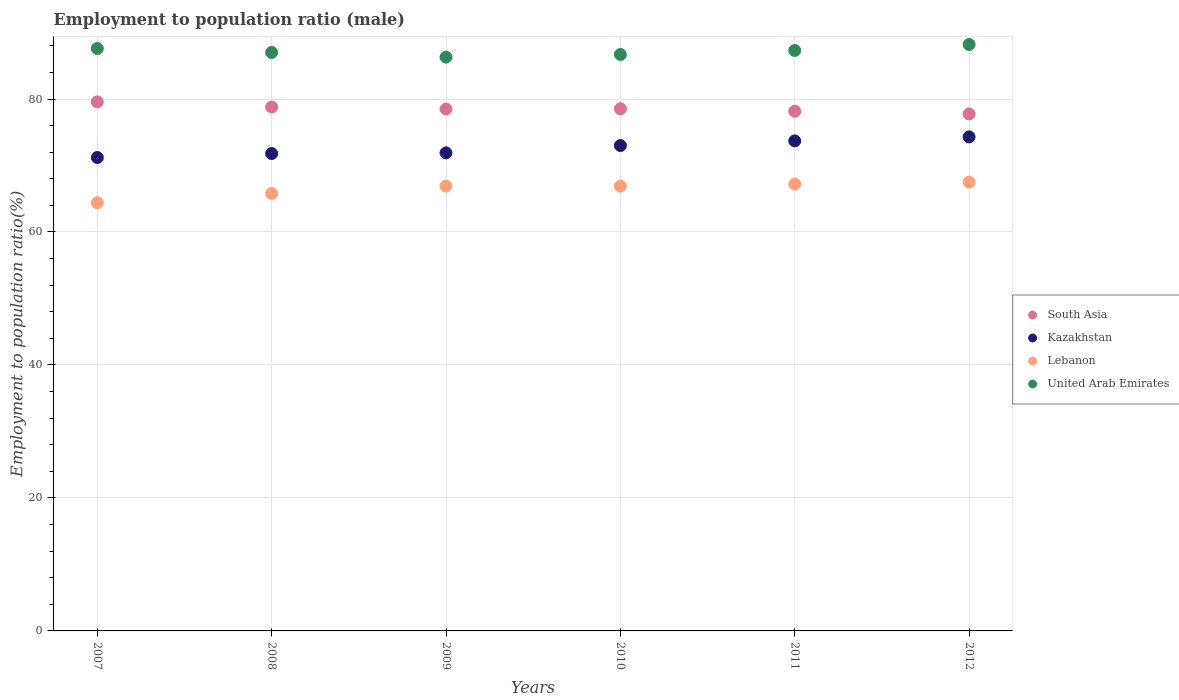How many different coloured dotlines are there?
Offer a terse response. 4. What is the employment to population ratio in Kazakhstan in 2009?
Give a very brief answer. 71.9. Across all years, what is the maximum employment to population ratio in Lebanon?
Your answer should be compact. 67.5. Across all years, what is the minimum employment to population ratio in Kazakhstan?
Make the answer very short. 71.2. What is the total employment to population ratio in Lebanon in the graph?
Keep it short and to the point. 398.7. What is the difference between the employment to population ratio in Kazakhstan in 2007 and that in 2009?
Keep it short and to the point. -0.7. What is the difference between the employment to population ratio in Lebanon in 2011 and the employment to population ratio in Kazakhstan in 2007?
Your response must be concise. -4. What is the average employment to population ratio in Lebanon per year?
Provide a succinct answer. 66.45. In the year 2012, what is the difference between the employment to population ratio in Lebanon and employment to population ratio in Kazakhstan?
Provide a succinct answer. -6.8. What is the ratio of the employment to population ratio in Lebanon in 2009 to that in 2012?
Your answer should be very brief. 0.99. Is the employment to population ratio in Kazakhstan in 2010 less than that in 2011?
Ensure brevity in your answer.  Yes. What is the difference between the highest and the second highest employment to population ratio in Lebanon?
Keep it short and to the point. 0.3. What is the difference between the highest and the lowest employment to population ratio in Kazakhstan?
Keep it short and to the point. 3.1. Is it the case that in every year, the sum of the employment to population ratio in South Asia and employment to population ratio in United Arab Emirates  is greater than the employment to population ratio in Lebanon?
Your response must be concise. Yes. Does the employment to population ratio in South Asia monotonically increase over the years?
Provide a short and direct response. No. Is the employment to population ratio in South Asia strictly less than the employment to population ratio in Lebanon over the years?
Your answer should be compact. No. How many years are there in the graph?
Offer a terse response. 6. What is the difference between two consecutive major ticks on the Y-axis?
Offer a terse response. 20. Does the graph contain grids?
Make the answer very short. Yes. How many legend labels are there?
Ensure brevity in your answer.  4. What is the title of the graph?
Your answer should be compact. Employment to population ratio (male). Does "Myanmar" appear as one of the legend labels in the graph?
Your answer should be compact. No. What is the label or title of the X-axis?
Your answer should be compact. Years. What is the label or title of the Y-axis?
Make the answer very short. Employment to population ratio(%). What is the Employment to population ratio(%) in South Asia in 2007?
Your answer should be compact. 79.56. What is the Employment to population ratio(%) in Kazakhstan in 2007?
Ensure brevity in your answer.  71.2. What is the Employment to population ratio(%) in Lebanon in 2007?
Provide a succinct answer. 64.4. What is the Employment to population ratio(%) of United Arab Emirates in 2007?
Your answer should be very brief. 87.6. What is the Employment to population ratio(%) of South Asia in 2008?
Provide a short and direct response. 78.8. What is the Employment to population ratio(%) in Kazakhstan in 2008?
Your response must be concise. 71.8. What is the Employment to population ratio(%) of Lebanon in 2008?
Provide a short and direct response. 65.8. What is the Employment to population ratio(%) of United Arab Emirates in 2008?
Offer a very short reply. 87. What is the Employment to population ratio(%) of South Asia in 2009?
Offer a very short reply. 78.49. What is the Employment to population ratio(%) in Kazakhstan in 2009?
Offer a very short reply. 71.9. What is the Employment to population ratio(%) in Lebanon in 2009?
Your answer should be very brief. 66.9. What is the Employment to population ratio(%) in United Arab Emirates in 2009?
Ensure brevity in your answer.  86.3. What is the Employment to population ratio(%) in South Asia in 2010?
Provide a short and direct response. 78.53. What is the Employment to population ratio(%) of Lebanon in 2010?
Offer a very short reply. 66.9. What is the Employment to population ratio(%) in United Arab Emirates in 2010?
Provide a succinct answer. 86.7. What is the Employment to population ratio(%) in South Asia in 2011?
Your answer should be very brief. 78.16. What is the Employment to population ratio(%) in Kazakhstan in 2011?
Give a very brief answer. 73.7. What is the Employment to population ratio(%) of Lebanon in 2011?
Provide a short and direct response. 67.2. What is the Employment to population ratio(%) of United Arab Emirates in 2011?
Provide a succinct answer. 87.3. What is the Employment to population ratio(%) of South Asia in 2012?
Ensure brevity in your answer.  77.76. What is the Employment to population ratio(%) in Kazakhstan in 2012?
Provide a short and direct response. 74.3. What is the Employment to population ratio(%) in Lebanon in 2012?
Give a very brief answer. 67.5. What is the Employment to population ratio(%) in United Arab Emirates in 2012?
Offer a terse response. 88.2. Across all years, what is the maximum Employment to population ratio(%) of South Asia?
Make the answer very short. 79.56. Across all years, what is the maximum Employment to population ratio(%) in Kazakhstan?
Provide a succinct answer. 74.3. Across all years, what is the maximum Employment to population ratio(%) of Lebanon?
Keep it short and to the point. 67.5. Across all years, what is the maximum Employment to population ratio(%) in United Arab Emirates?
Offer a terse response. 88.2. Across all years, what is the minimum Employment to population ratio(%) in South Asia?
Provide a short and direct response. 77.76. Across all years, what is the minimum Employment to population ratio(%) of Kazakhstan?
Your response must be concise. 71.2. Across all years, what is the minimum Employment to population ratio(%) of Lebanon?
Offer a terse response. 64.4. Across all years, what is the minimum Employment to population ratio(%) of United Arab Emirates?
Keep it short and to the point. 86.3. What is the total Employment to population ratio(%) of South Asia in the graph?
Offer a very short reply. 471.3. What is the total Employment to population ratio(%) in Kazakhstan in the graph?
Provide a succinct answer. 435.9. What is the total Employment to population ratio(%) in Lebanon in the graph?
Provide a short and direct response. 398.7. What is the total Employment to population ratio(%) of United Arab Emirates in the graph?
Your response must be concise. 523.1. What is the difference between the Employment to population ratio(%) in South Asia in 2007 and that in 2008?
Your answer should be compact. 0.76. What is the difference between the Employment to population ratio(%) in Kazakhstan in 2007 and that in 2008?
Ensure brevity in your answer.  -0.6. What is the difference between the Employment to population ratio(%) of South Asia in 2007 and that in 2009?
Offer a very short reply. 1.07. What is the difference between the Employment to population ratio(%) in Kazakhstan in 2007 and that in 2009?
Provide a short and direct response. -0.7. What is the difference between the Employment to population ratio(%) in Lebanon in 2007 and that in 2009?
Keep it short and to the point. -2.5. What is the difference between the Employment to population ratio(%) in South Asia in 2007 and that in 2010?
Keep it short and to the point. 1.03. What is the difference between the Employment to population ratio(%) of Kazakhstan in 2007 and that in 2010?
Offer a very short reply. -1.8. What is the difference between the Employment to population ratio(%) of South Asia in 2007 and that in 2011?
Your response must be concise. 1.41. What is the difference between the Employment to population ratio(%) in South Asia in 2007 and that in 2012?
Offer a very short reply. 1.8. What is the difference between the Employment to population ratio(%) of Kazakhstan in 2007 and that in 2012?
Make the answer very short. -3.1. What is the difference between the Employment to population ratio(%) of South Asia in 2008 and that in 2009?
Provide a succinct answer. 0.32. What is the difference between the Employment to population ratio(%) in Kazakhstan in 2008 and that in 2009?
Keep it short and to the point. -0.1. What is the difference between the Employment to population ratio(%) in South Asia in 2008 and that in 2010?
Your response must be concise. 0.27. What is the difference between the Employment to population ratio(%) in United Arab Emirates in 2008 and that in 2010?
Offer a very short reply. 0.3. What is the difference between the Employment to population ratio(%) in South Asia in 2008 and that in 2011?
Offer a very short reply. 0.65. What is the difference between the Employment to population ratio(%) of South Asia in 2008 and that in 2012?
Offer a terse response. 1.04. What is the difference between the Employment to population ratio(%) in Kazakhstan in 2008 and that in 2012?
Keep it short and to the point. -2.5. What is the difference between the Employment to population ratio(%) of Lebanon in 2008 and that in 2012?
Make the answer very short. -1.7. What is the difference between the Employment to population ratio(%) of United Arab Emirates in 2008 and that in 2012?
Provide a short and direct response. -1.2. What is the difference between the Employment to population ratio(%) in South Asia in 2009 and that in 2010?
Keep it short and to the point. -0.04. What is the difference between the Employment to population ratio(%) in Kazakhstan in 2009 and that in 2010?
Offer a very short reply. -1.1. What is the difference between the Employment to population ratio(%) in United Arab Emirates in 2009 and that in 2010?
Give a very brief answer. -0.4. What is the difference between the Employment to population ratio(%) of South Asia in 2009 and that in 2011?
Provide a succinct answer. 0.33. What is the difference between the Employment to population ratio(%) in Kazakhstan in 2009 and that in 2011?
Your answer should be compact. -1.8. What is the difference between the Employment to population ratio(%) in Lebanon in 2009 and that in 2011?
Provide a succinct answer. -0.3. What is the difference between the Employment to population ratio(%) in South Asia in 2009 and that in 2012?
Offer a terse response. 0.73. What is the difference between the Employment to population ratio(%) in Kazakhstan in 2009 and that in 2012?
Keep it short and to the point. -2.4. What is the difference between the Employment to population ratio(%) in South Asia in 2010 and that in 2011?
Offer a terse response. 0.37. What is the difference between the Employment to population ratio(%) of South Asia in 2010 and that in 2012?
Provide a succinct answer. 0.77. What is the difference between the Employment to population ratio(%) in United Arab Emirates in 2010 and that in 2012?
Provide a succinct answer. -1.5. What is the difference between the Employment to population ratio(%) of South Asia in 2011 and that in 2012?
Offer a terse response. 0.4. What is the difference between the Employment to population ratio(%) in United Arab Emirates in 2011 and that in 2012?
Give a very brief answer. -0.9. What is the difference between the Employment to population ratio(%) in South Asia in 2007 and the Employment to population ratio(%) in Kazakhstan in 2008?
Make the answer very short. 7.76. What is the difference between the Employment to population ratio(%) in South Asia in 2007 and the Employment to population ratio(%) in Lebanon in 2008?
Your answer should be very brief. 13.76. What is the difference between the Employment to population ratio(%) of South Asia in 2007 and the Employment to population ratio(%) of United Arab Emirates in 2008?
Make the answer very short. -7.44. What is the difference between the Employment to population ratio(%) of Kazakhstan in 2007 and the Employment to population ratio(%) of Lebanon in 2008?
Your answer should be compact. 5.4. What is the difference between the Employment to population ratio(%) in Kazakhstan in 2007 and the Employment to population ratio(%) in United Arab Emirates in 2008?
Make the answer very short. -15.8. What is the difference between the Employment to population ratio(%) in Lebanon in 2007 and the Employment to population ratio(%) in United Arab Emirates in 2008?
Your answer should be very brief. -22.6. What is the difference between the Employment to population ratio(%) of South Asia in 2007 and the Employment to population ratio(%) of Kazakhstan in 2009?
Your response must be concise. 7.66. What is the difference between the Employment to population ratio(%) of South Asia in 2007 and the Employment to population ratio(%) of Lebanon in 2009?
Your response must be concise. 12.66. What is the difference between the Employment to population ratio(%) of South Asia in 2007 and the Employment to population ratio(%) of United Arab Emirates in 2009?
Provide a succinct answer. -6.74. What is the difference between the Employment to population ratio(%) of Kazakhstan in 2007 and the Employment to population ratio(%) of Lebanon in 2009?
Your answer should be compact. 4.3. What is the difference between the Employment to population ratio(%) in Kazakhstan in 2007 and the Employment to population ratio(%) in United Arab Emirates in 2009?
Provide a short and direct response. -15.1. What is the difference between the Employment to population ratio(%) of Lebanon in 2007 and the Employment to population ratio(%) of United Arab Emirates in 2009?
Make the answer very short. -21.9. What is the difference between the Employment to population ratio(%) in South Asia in 2007 and the Employment to population ratio(%) in Kazakhstan in 2010?
Ensure brevity in your answer.  6.56. What is the difference between the Employment to population ratio(%) of South Asia in 2007 and the Employment to population ratio(%) of Lebanon in 2010?
Offer a terse response. 12.66. What is the difference between the Employment to population ratio(%) in South Asia in 2007 and the Employment to population ratio(%) in United Arab Emirates in 2010?
Provide a succinct answer. -7.14. What is the difference between the Employment to population ratio(%) in Kazakhstan in 2007 and the Employment to population ratio(%) in United Arab Emirates in 2010?
Your response must be concise. -15.5. What is the difference between the Employment to population ratio(%) in Lebanon in 2007 and the Employment to population ratio(%) in United Arab Emirates in 2010?
Your answer should be very brief. -22.3. What is the difference between the Employment to population ratio(%) of South Asia in 2007 and the Employment to population ratio(%) of Kazakhstan in 2011?
Offer a terse response. 5.86. What is the difference between the Employment to population ratio(%) in South Asia in 2007 and the Employment to population ratio(%) in Lebanon in 2011?
Ensure brevity in your answer.  12.36. What is the difference between the Employment to population ratio(%) of South Asia in 2007 and the Employment to population ratio(%) of United Arab Emirates in 2011?
Provide a short and direct response. -7.74. What is the difference between the Employment to population ratio(%) in Kazakhstan in 2007 and the Employment to population ratio(%) in Lebanon in 2011?
Your answer should be compact. 4. What is the difference between the Employment to population ratio(%) of Kazakhstan in 2007 and the Employment to population ratio(%) of United Arab Emirates in 2011?
Give a very brief answer. -16.1. What is the difference between the Employment to population ratio(%) in Lebanon in 2007 and the Employment to population ratio(%) in United Arab Emirates in 2011?
Keep it short and to the point. -22.9. What is the difference between the Employment to population ratio(%) of South Asia in 2007 and the Employment to population ratio(%) of Kazakhstan in 2012?
Ensure brevity in your answer.  5.26. What is the difference between the Employment to population ratio(%) in South Asia in 2007 and the Employment to population ratio(%) in Lebanon in 2012?
Make the answer very short. 12.06. What is the difference between the Employment to population ratio(%) of South Asia in 2007 and the Employment to population ratio(%) of United Arab Emirates in 2012?
Make the answer very short. -8.64. What is the difference between the Employment to population ratio(%) of Lebanon in 2007 and the Employment to population ratio(%) of United Arab Emirates in 2012?
Your answer should be very brief. -23.8. What is the difference between the Employment to population ratio(%) of South Asia in 2008 and the Employment to population ratio(%) of Kazakhstan in 2009?
Make the answer very short. 6.9. What is the difference between the Employment to population ratio(%) of South Asia in 2008 and the Employment to population ratio(%) of Lebanon in 2009?
Offer a terse response. 11.9. What is the difference between the Employment to population ratio(%) in South Asia in 2008 and the Employment to population ratio(%) in United Arab Emirates in 2009?
Offer a terse response. -7.5. What is the difference between the Employment to population ratio(%) of Kazakhstan in 2008 and the Employment to population ratio(%) of United Arab Emirates in 2009?
Keep it short and to the point. -14.5. What is the difference between the Employment to population ratio(%) in Lebanon in 2008 and the Employment to population ratio(%) in United Arab Emirates in 2009?
Give a very brief answer. -20.5. What is the difference between the Employment to population ratio(%) of South Asia in 2008 and the Employment to population ratio(%) of Kazakhstan in 2010?
Your answer should be compact. 5.8. What is the difference between the Employment to population ratio(%) in South Asia in 2008 and the Employment to population ratio(%) in Lebanon in 2010?
Make the answer very short. 11.9. What is the difference between the Employment to population ratio(%) in South Asia in 2008 and the Employment to population ratio(%) in United Arab Emirates in 2010?
Offer a very short reply. -7.9. What is the difference between the Employment to population ratio(%) in Kazakhstan in 2008 and the Employment to population ratio(%) in Lebanon in 2010?
Ensure brevity in your answer.  4.9. What is the difference between the Employment to population ratio(%) in Kazakhstan in 2008 and the Employment to population ratio(%) in United Arab Emirates in 2010?
Your answer should be compact. -14.9. What is the difference between the Employment to population ratio(%) in Lebanon in 2008 and the Employment to population ratio(%) in United Arab Emirates in 2010?
Your response must be concise. -20.9. What is the difference between the Employment to population ratio(%) of South Asia in 2008 and the Employment to population ratio(%) of Kazakhstan in 2011?
Offer a very short reply. 5.1. What is the difference between the Employment to population ratio(%) in South Asia in 2008 and the Employment to population ratio(%) in Lebanon in 2011?
Make the answer very short. 11.6. What is the difference between the Employment to population ratio(%) of South Asia in 2008 and the Employment to population ratio(%) of United Arab Emirates in 2011?
Your answer should be very brief. -8.5. What is the difference between the Employment to population ratio(%) in Kazakhstan in 2008 and the Employment to population ratio(%) in United Arab Emirates in 2011?
Your response must be concise. -15.5. What is the difference between the Employment to population ratio(%) of Lebanon in 2008 and the Employment to population ratio(%) of United Arab Emirates in 2011?
Your response must be concise. -21.5. What is the difference between the Employment to population ratio(%) of South Asia in 2008 and the Employment to population ratio(%) of Kazakhstan in 2012?
Your answer should be very brief. 4.5. What is the difference between the Employment to population ratio(%) in South Asia in 2008 and the Employment to population ratio(%) in Lebanon in 2012?
Keep it short and to the point. 11.3. What is the difference between the Employment to population ratio(%) in South Asia in 2008 and the Employment to population ratio(%) in United Arab Emirates in 2012?
Provide a succinct answer. -9.4. What is the difference between the Employment to population ratio(%) in Kazakhstan in 2008 and the Employment to population ratio(%) in United Arab Emirates in 2012?
Give a very brief answer. -16.4. What is the difference between the Employment to population ratio(%) of Lebanon in 2008 and the Employment to population ratio(%) of United Arab Emirates in 2012?
Offer a very short reply. -22.4. What is the difference between the Employment to population ratio(%) in South Asia in 2009 and the Employment to population ratio(%) in Kazakhstan in 2010?
Your answer should be compact. 5.49. What is the difference between the Employment to population ratio(%) of South Asia in 2009 and the Employment to population ratio(%) of Lebanon in 2010?
Make the answer very short. 11.59. What is the difference between the Employment to population ratio(%) of South Asia in 2009 and the Employment to population ratio(%) of United Arab Emirates in 2010?
Your answer should be very brief. -8.21. What is the difference between the Employment to population ratio(%) of Kazakhstan in 2009 and the Employment to population ratio(%) of United Arab Emirates in 2010?
Provide a succinct answer. -14.8. What is the difference between the Employment to population ratio(%) of Lebanon in 2009 and the Employment to population ratio(%) of United Arab Emirates in 2010?
Provide a succinct answer. -19.8. What is the difference between the Employment to population ratio(%) in South Asia in 2009 and the Employment to population ratio(%) in Kazakhstan in 2011?
Your response must be concise. 4.79. What is the difference between the Employment to population ratio(%) of South Asia in 2009 and the Employment to population ratio(%) of Lebanon in 2011?
Make the answer very short. 11.29. What is the difference between the Employment to population ratio(%) in South Asia in 2009 and the Employment to population ratio(%) in United Arab Emirates in 2011?
Ensure brevity in your answer.  -8.81. What is the difference between the Employment to population ratio(%) of Kazakhstan in 2009 and the Employment to population ratio(%) of United Arab Emirates in 2011?
Provide a short and direct response. -15.4. What is the difference between the Employment to population ratio(%) in Lebanon in 2009 and the Employment to population ratio(%) in United Arab Emirates in 2011?
Keep it short and to the point. -20.4. What is the difference between the Employment to population ratio(%) of South Asia in 2009 and the Employment to population ratio(%) of Kazakhstan in 2012?
Keep it short and to the point. 4.19. What is the difference between the Employment to population ratio(%) of South Asia in 2009 and the Employment to population ratio(%) of Lebanon in 2012?
Your answer should be compact. 10.99. What is the difference between the Employment to population ratio(%) of South Asia in 2009 and the Employment to population ratio(%) of United Arab Emirates in 2012?
Keep it short and to the point. -9.71. What is the difference between the Employment to population ratio(%) in Kazakhstan in 2009 and the Employment to population ratio(%) in Lebanon in 2012?
Your response must be concise. 4.4. What is the difference between the Employment to population ratio(%) of Kazakhstan in 2009 and the Employment to population ratio(%) of United Arab Emirates in 2012?
Provide a short and direct response. -16.3. What is the difference between the Employment to population ratio(%) of Lebanon in 2009 and the Employment to population ratio(%) of United Arab Emirates in 2012?
Give a very brief answer. -21.3. What is the difference between the Employment to population ratio(%) in South Asia in 2010 and the Employment to population ratio(%) in Kazakhstan in 2011?
Make the answer very short. 4.83. What is the difference between the Employment to population ratio(%) in South Asia in 2010 and the Employment to population ratio(%) in Lebanon in 2011?
Your response must be concise. 11.33. What is the difference between the Employment to population ratio(%) of South Asia in 2010 and the Employment to population ratio(%) of United Arab Emirates in 2011?
Your answer should be very brief. -8.77. What is the difference between the Employment to population ratio(%) of Kazakhstan in 2010 and the Employment to population ratio(%) of Lebanon in 2011?
Keep it short and to the point. 5.8. What is the difference between the Employment to population ratio(%) in Kazakhstan in 2010 and the Employment to population ratio(%) in United Arab Emirates in 2011?
Offer a terse response. -14.3. What is the difference between the Employment to population ratio(%) of Lebanon in 2010 and the Employment to population ratio(%) of United Arab Emirates in 2011?
Provide a succinct answer. -20.4. What is the difference between the Employment to population ratio(%) in South Asia in 2010 and the Employment to population ratio(%) in Kazakhstan in 2012?
Offer a very short reply. 4.23. What is the difference between the Employment to population ratio(%) in South Asia in 2010 and the Employment to population ratio(%) in Lebanon in 2012?
Ensure brevity in your answer.  11.03. What is the difference between the Employment to population ratio(%) in South Asia in 2010 and the Employment to population ratio(%) in United Arab Emirates in 2012?
Offer a very short reply. -9.67. What is the difference between the Employment to population ratio(%) of Kazakhstan in 2010 and the Employment to population ratio(%) of United Arab Emirates in 2012?
Give a very brief answer. -15.2. What is the difference between the Employment to population ratio(%) of Lebanon in 2010 and the Employment to population ratio(%) of United Arab Emirates in 2012?
Your answer should be compact. -21.3. What is the difference between the Employment to population ratio(%) of South Asia in 2011 and the Employment to population ratio(%) of Kazakhstan in 2012?
Make the answer very short. 3.86. What is the difference between the Employment to population ratio(%) of South Asia in 2011 and the Employment to population ratio(%) of Lebanon in 2012?
Offer a terse response. 10.66. What is the difference between the Employment to population ratio(%) in South Asia in 2011 and the Employment to population ratio(%) in United Arab Emirates in 2012?
Keep it short and to the point. -10.04. What is the difference between the Employment to population ratio(%) in Kazakhstan in 2011 and the Employment to population ratio(%) in Lebanon in 2012?
Provide a succinct answer. 6.2. What is the difference between the Employment to population ratio(%) in Kazakhstan in 2011 and the Employment to population ratio(%) in United Arab Emirates in 2012?
Provide a short and direct response. -14.5. What is the average Employment to population ratio(%) in South Asia per year?
Offer a very short reply. 78.55. What is the average Employment to population ratio(%) of Kazakhstan per year?
Offer a terse response. 72.65. What is the average Employment to population ratio(%) in Lebanon per year?
Your answer should be very brief. 66.45. What is the average Employment to population ratio(%) of United Arab Emirates per year?
Give a very brief answer. 87.18. In the year 2007, what is the difference between the Employment to population ratio(%) of South Asia and Employment to population ratio(%) of Kazakhstan?
Keep it short and to the point. 8.36. In the year 2007, what is the difference between the Employment to population ratio(%) of South Asia and Employment to population ratio(%) of Lebanon?
Give a very brief answer. 15.16. In the year 2007, what is the difference between the Employment to population ratio(%) of South Asia and Employment to population ratio(%) of United Arab Emirates?
Provide a short and direct response. -8.04. In the year 2007, what is the difference between the Employment to population ratio(%) in Kazakhstan and Employment to population ratio(%) in United Arab Emirates?
Make the answer very short. -16.4. In the year 2007, what is the difference between the Employment to population ratio(%) of Lebanon and Employment to population ratio(%) of United Arab Emirates?
Make the answer very short. -23.2. In the year 2008, what is the difference between the Employment to population ratio(%) in South Asia and Employment to population ratio(%) in Kazakhstan?
Make the answer very short. 7. In the year 2008, what is the difference between the Employment to population ratio(%) of South Asia and Employment to population ratio(%) of Lebanon?
Provide a short and direct response. 13. In the year 2008, what is the difference between the Employment to population ratio(%) of South Asia and Employment to population ratio(%) of United Arab Emirates?
Ensure brevity in your answer.  -8.2. In the year 2008, what is the difference between the Employment to population ratio(%) of Kazakhstan and Employment to population ratio(%) of United Arab Emirates?
Your answer should be very brief. -15.2. In the year 2008, what is the difference between the Employment to population ratio(%) in Lebanon and Employment to population ratio(%) in United Arab Emirates?
Ensure brevity in your answer.  -21.2. In the year 2009, what is the difference between the Employment to population ratio(%) of South Asia and Employment to population ratio(%) of Kazakhstan?
Offer a very short reply. 6.59. In the year 2009, what is the difference between the Employment to population ratio(%) in South Asia and Employment to population ratio(%) in Lebanon?
Your response must be concise. 11.59. In the year 2009, what is the difference between the Employment to population ratio(%) of South Asia and Employment to population ratio(%) of United Arab Emirates?
Keep it short and to the point. -7.81. In the year 2009, what is the difference between the Employment to population ratio(%) of Kazakhstan and Employment to population ratio(%) of United Arab Emirates?
Ensure brevity in your answer.  -14.4. In the year 2009, what is the difference between the Employment to population ratio(%) in Lebanon and Employment to population ratio(%) in United Arab Emirates?
Offer a terse response. -19.4. In the year 2010, what is the difference between the Employment to population ratio(%) of South Asia and Employment to population ratio(%) of Kazakhstan?
Keep it short and to the point. 5.53. In the year 2010, what is the difference between the Employment to population ratio(%) in South Asia and Employment to population ratio(%) in Lebanon?
Offer a terse response. 11.63. In the year 2010, what is the difference between the Employment to population ratio(%) of South Asia and Employment to population ratio(%) of United Arab Emirates?
Your response must be concise. -8.17. In the year 2010, what is the difference between the Employment to population ratio(%) of Kazakhstan and Employment to population ratio(%) of United Arab Emirates?
Keep it short and to the point. -13.7. In the year 2010, what is the difference between the Employment to population ratio(%) in Lebanon and Employment to population ratio(%) in United Arab Emirates?
Provide a succinct answer. -19.8. In the year 2011, what is the difference between the Employment to population ratio(%) of South Asia and Employment to population ratio(%) of Kazakhstan?
Keep it short and to the point. 4.46. In the year 2011, what is the difference between the Employment to population ratio(%) of South Asia and Employment to population ratio(%) of Lebanon?
Ensure brevity in your answer.  10.96. In the year 2011, what is the difference between the Employment to population ratio(%) of South Asia and Employment to population ratio(%) of United Arab Emirates?
Provide a succinct answer. -9.14. In the year 2011, what is the difference between the Employment to population ratio(%) of Kazakhstan and Employment to population ratio(%) of Lebanon?
Give a very brief answer. 6.5. In the year 2011, what is the difference between the Employment to population ratio(%) in Kazakhstan and Employment to population ratio(%) in United Arab Emirates?
Your answer should be compact. -13.6. In the year 2011, what is the difference between the Employment to population ratio(%) of Lebanon and Employment to population ratio(%) of United Arab Emirates?
Give a very brief answer. -20.1. In the year 2012, what is the difference between the Employment to population ratio(%) of South Asia and Employment to population ratio(%) of Kazakhstan?
Ensure brevity in your answer.  3.46. In the year 2012, what is the difference between the Employment to population ratio(%) of South Asia and Employment to population ratio(%) of Lebanon?
Offer a very short reply. 10.26. In the year 2012, what is the difference between the Employment to population ratio(%) of South Asia and Employment to population ratio(%) of United Arab Emirates?
Your answer should be compact. -10.44. In the year 2012, what is the difference between the Employment to population ratio(%) of Kazakhstan and Employment to population ratio(%) of Lebanon?
Ensure brevity in your answer.  6.8. In the year 2012, what is the difference between the Employment to population ratio(%) in Kazakhstan and Employment to population ratio(%) in United Arab Emirates?
Ensure brevity in your answer.  -13.9. In the year 2012, what is the difference between the Employment to population ratio(%) of Lebanon and Employment to population ratio(%) of United Arab Emirates?
Your answer should be compact. -20.7. What is the ratio of the Employment to population ratio(%) of South Asia in 2007 to that in 2008?
Give a very brief answer. 1.01. What is the ratio of the Employment to population ratio(%) in Lebanon in 2007 to that in 2008?
Offer a very short reply. 0.98. What is the ratio of the Employment to population ratio(%) of South Asia in 2007 to that in 2009?
Offer a terse response. 1.01. What is the ratio of the Employment to population ratio(%) of Kazakhstan in 2007 to that in 2009?
Give a very brief answer. 0.99. What is the ratio of the Employment to population ratio(%) of Lebanon in 2007 to that in 2009?
Your answer should be very brief. 0.96. What is the ratio of the Employment to population ratio(%) in United Arab Emirates in 2007 to that in 2009?
Provide a short and direct response. 1.02. What is the ratio of the Employment to population ratio(%) in South Asia in 2007 to that in 2010?
Ensure brevity in your answer.  1.01. What is the ratio of the Employment to population ratio(%) of Kazakhstan in 2007 to that in 2010?
Your answer should be very brief. 0.98. What is the ratio of the Employment to population ratio(%) of Lebanon in 2007 to that in 2010?
Ensure brevity in your answer.  0.96. What is the ratio of the Employment to population ratio(%) of United Arab Emirates in 2007 to that in 2010?
Your answer should be very brief. 1.01. What is the ratio of the Employment to population ratio(%) in South Asia in 2007 to that in 2011?
Provide a short and direct response. 1.02. What is the ratio of the Employment to population ratio(%) in Kazakhstan in 2007 to that in 2011?
Your response must be concise. 0.97. What is the ratio of the Employment to population ratio(%) of South Asia in 2007 to that in 2012?
Your answer should be very brief. 1.02. What is the ratio of the Employment to population ratio(%) in Kazakhstan in 2007 to that in 2012?
Your answer should be very brief. 0.96. What is the ratio of the Employment to population ratio(%) of Lebanon in 2007 to that in 2012?
Keep it short and to the point. 0.95. What is the ratio of the Employment to population ratio(%) of United Arab Emirates in 2007 to that in 2012?
Your answer should be compact. 0.99. What is the ratio of the Employment to population ratio(%) in Kazakhstan in 2008 to that in 2009?
Provide a short and direct response. 1. What is the ratio of the Employment to population ratio(%) in Lebanon in 2008 to that in 2009?
Your answer should be compact. 0.98. What is the ratio of the Employment to population ratio(%) of United Arab Emirates in 2008 to that in 2009?
Keep it short and to the point. 1.01. What is the ratio of the Employment to population ratio(%) of Kazakhstan in 2008 to that in 2010?
Your answer should be compact. 0.98. What is the ratio of the Employment to population ratio(%) of Lebanon in 2008 to that in 2010?
Offer a very short reply. 0.98. What is the ratio of the Employment to population ratio(%) in South Asia in 2008 to that in 2011?
Ensure brevity in your answer.  1.01. What is the ratio of the Employment to population ratio(%) in Kazakhstan in 2008 to that in 2011?
Give a very brief answer. 0.97. What is the ratio of the Employment to population ratio(%) of Lebanon in 2008 to that in 2011?
Your answer should be compact. 0.98. What is the ratio of the Employment to population ratio(%) of South Asia in 2008 to that in 2012?
Provide a succinct answer. 1.01. What is the ratio of the Employment to population ratio(%) in Kazakhstan in 2008 to that in 2012?
Offer a very short reply. 0.97. What is the ratio of the Employment to population ratio(%) of Lebanon in 2008 to that in 2012?
Provide a succinct answer. 0.97. What is the ratio of the Employment to population ratio(%) of United Arab Emirates in 2008 to that in 2012?
Your answer should be very brief. 0.99. What is the ratio of the Employment to population ratio(%) in South Asia in 2009 to that in 2010?
Your answer should be compact. 1. What is the ratio of the Employment to population ratio(%) of Kazakhstan in 2009 to that in 2010?
Offer a very short reply. 0.98. What is the ratio of the Employment to population ratio(%) of Lebanon in 2009 to that in 2010?
Provide a succinct answer. 1. What is the ratio of the Employment to population ratio(%) in South Asia in 2009 to that in 2011?
Provide a short and direct response. 1. What is the ratio of the Employment to population ratio(%) of Kazakhstan in 2009 to that in 2011?
Offer a very short reply. 0.98. What is the ratio of the Employment to population ratio(%) of Lebanon in 2009 to that in 2011?
Your answer should be very brief. 1. What is the ratio of the Employment to population ratio(%) of South Asia in 2009 to that in 2012?
Your response must be concise. 1.01. What is the ratio of the Employment to population ratio(%) of Lebanon in 2009 to that in 2012?
Keep it short and to the point. 0.99. What is the ratio of the Employment to population ratio(%) in United Arab Emirates in 2009 to that in 2012?
Ensure brevity in your answer.  0.98. What is the ratio of the Employment to population ratio(%) of South Asia in 2010 to that in 2011?
Your answer should be very brief. 1. What is the ratio of the Employment to population ratio(%) in Kazakhstan in 2010 to that in 2011?
Ensure brevity in your answer.  0.99. What is the ratio of the Employment to population ratio(%) of United Arab Emirates in 2010 to that in 2011?
Provide a short and direct response. 0.99. What is the ratio of the Employment to population ratio(%) in South Asia in 2010 to that in 2012?
Give a very brief answer. 1.01. What is the ratio of the Employment to population ratio(%) in Kazakhstan in 2010 to that in 2012?
Give a very brief answer. 0.98. What is the ratio of the Employment to population ratio(%) in United Arab Emirates in 2010 to that in 2012?
Your answer should be compact. 0.98. What is the ratio of the Employment to population ratio(%) of South Asia in 2011 to that in 2012?
Offer a very short reply. 1.01. What is the ratio of the Employment to population ratio(%) in Lebanon in 2011 to that in 2012?
Keep it short and to the point. 1. What is the ratio of the Employment to population ratio(%) in United Arab Emirates in 2011 to that in 2012?
Your response must be concise. 0.99. What is the difference between the highest and the second highest Employment to population ratio(%) in South Asia?
Your answer should be compact. 0.76. What is the difference between the highest and the second highest Employment to population ratio(%) of United Arab Emirates?
Offer a very short reply. 0.6. What is the difference between the highest and the lowest Employment to population ratio(%) of South Asia?
Keep it short and to the point. 1.8. What is the difference between the highest and the lowest Employment to population ratio(%) in Kazakhstan?
Provide a short and direct response. 3.1. What is the difference between the highest and the lowest Employment to population ratio(%) in Lebanon?
Give a very brief answer. 3.1. What is the difference between the highest and the lowest Employment to population ratio(%) of United Arab Emirates?
Provide a short and direct response. 1.9. 